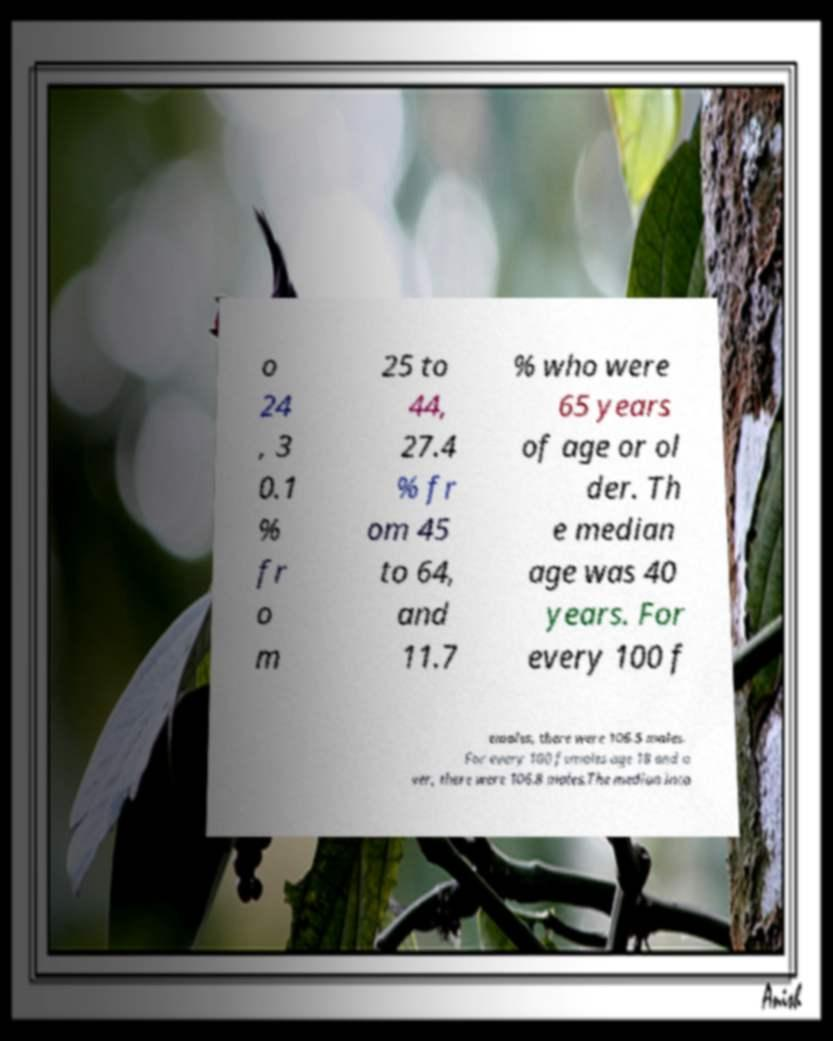Could you assist in decoding the text presented in this image and type it out clearly? o 24 , 3 0.1 % fr o m 25 to 44, 27.4 % fr om 45 to 64, and 11.7 % who were 65 years of age or ol der. Th e median age was 40 years. For every 100 f emales, there were 106.5 males. For every 100 females age 18 and o ver, there were 106.8 males.The median inco 